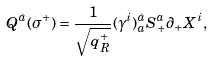<formula> <loc_0><loc_0><loc_500><loc_500>Q ^ { \dot { a } } ( \sigma ^ { + } ) = \frac { 1 } { \sqrt { q ^ { + } _ { R } } } ( \gamma ^ { i } ) ^ { \dot { a } } _ { a } S ^ { a } _ { + } \partial _ { + } X ^ { i } ,</formula> 